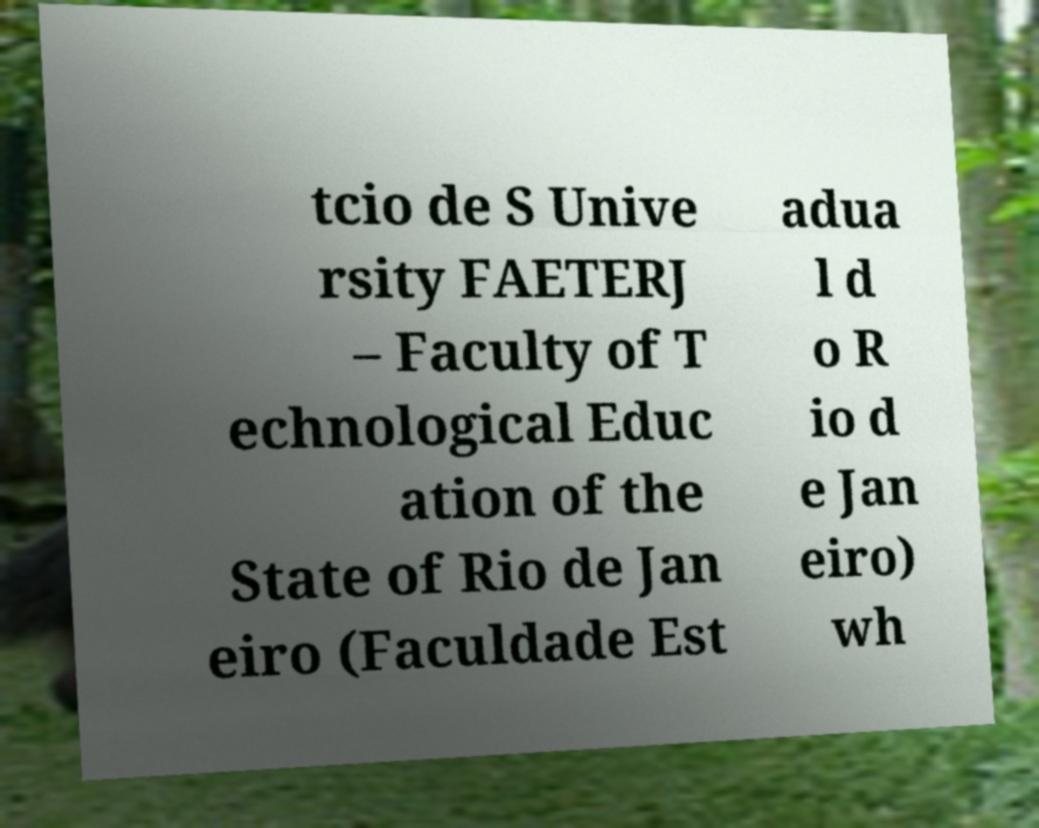What messages or text are displayed in this image? I need them in a readable, typed format. tcio de S Unive rsity FAETERJ – Faculty of T echnological Educ ation of the State of Rio de Jan eiro (Faculdade Est adua l d o R io d e Jan eiro) wh 